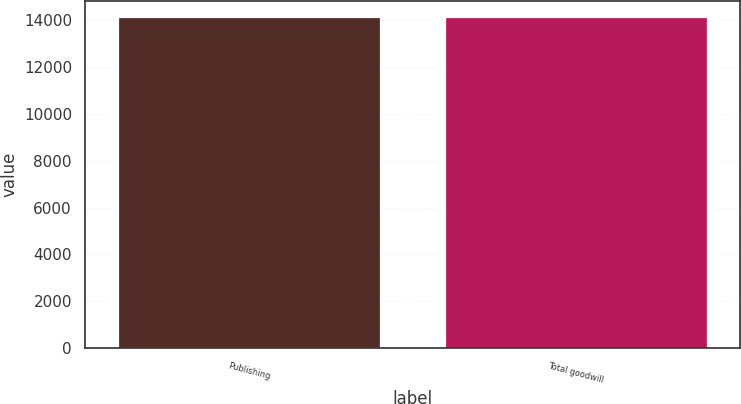Convert chart. <chart><loc_0><loc_0><loc_500><loc_500><bar_chart><fcel>Publishing<fcel>Total goodwill<nl><fcel>14129<fcel>14129.1<nl></chart> 